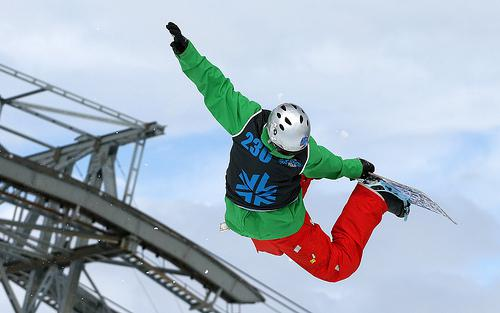Question: what sport is this?
Choices:
A. Skiing.
B. Curling.
C. Snowboarding.
D. Hockey.
Answer with the letter. Answer: C Question: where is the helmet?
Choices:
A. On the ground.
B. On a hook.
C. On the man's head.
D. In a bag.
Answer with the letter. Answer: C Question: who is wearing orange pants?
Choices:
A. Skiier.
B. Snowboarder.
C. Skateboarder.
D. Bicyclist.
Answer with the letter. Answer: B Question: what number is on the man's chest?
Choices:
A. 22.
B. 24.
C. 30.
D. 230.
Answer with the letter. Answer: D 